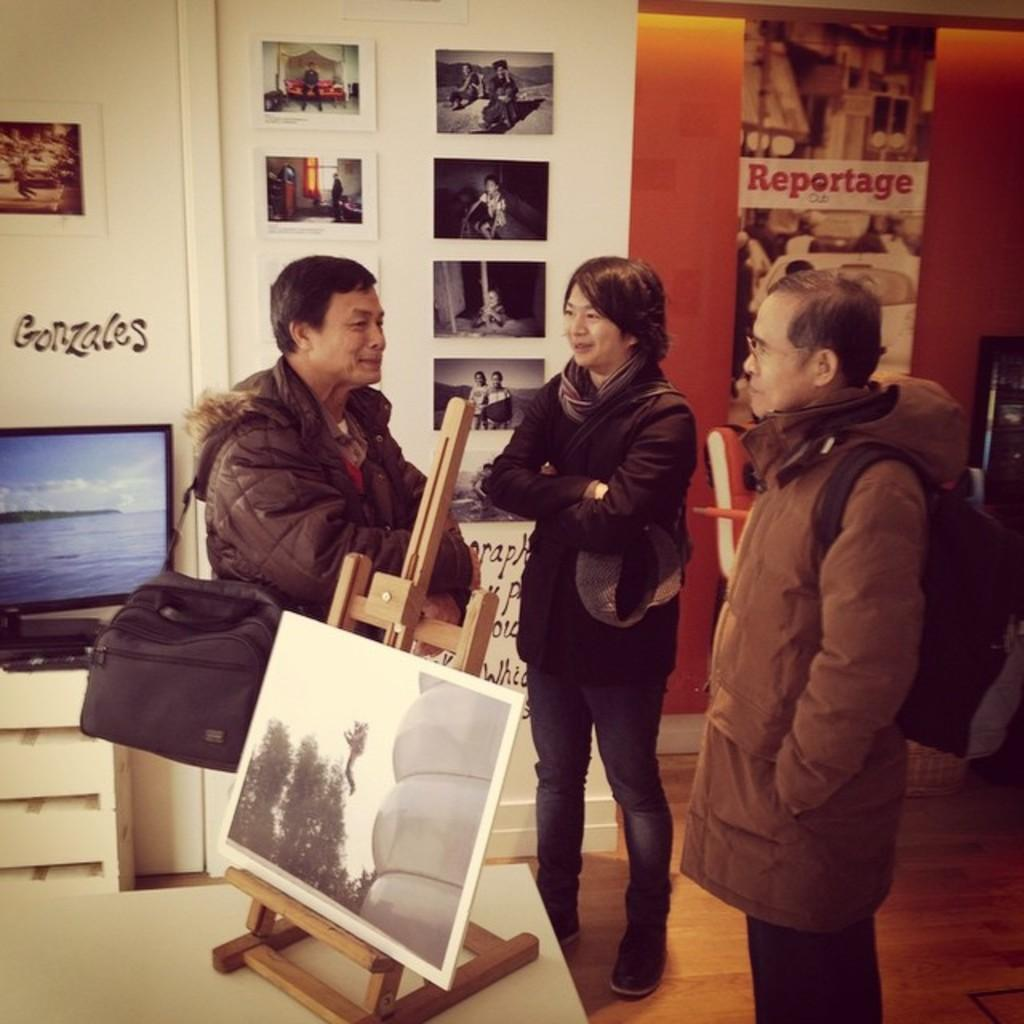How many people are in the image? There are 3 people in the image. What are the people wearing? The people are wearing jackets. What can be seen in the image besides the people? There is a photo, a wooden stand, photo frames, and a screen at the back in the image. How hot is the temperature in the image? The temperature is not mentioned in the image, so we cannot determine the heat level. 